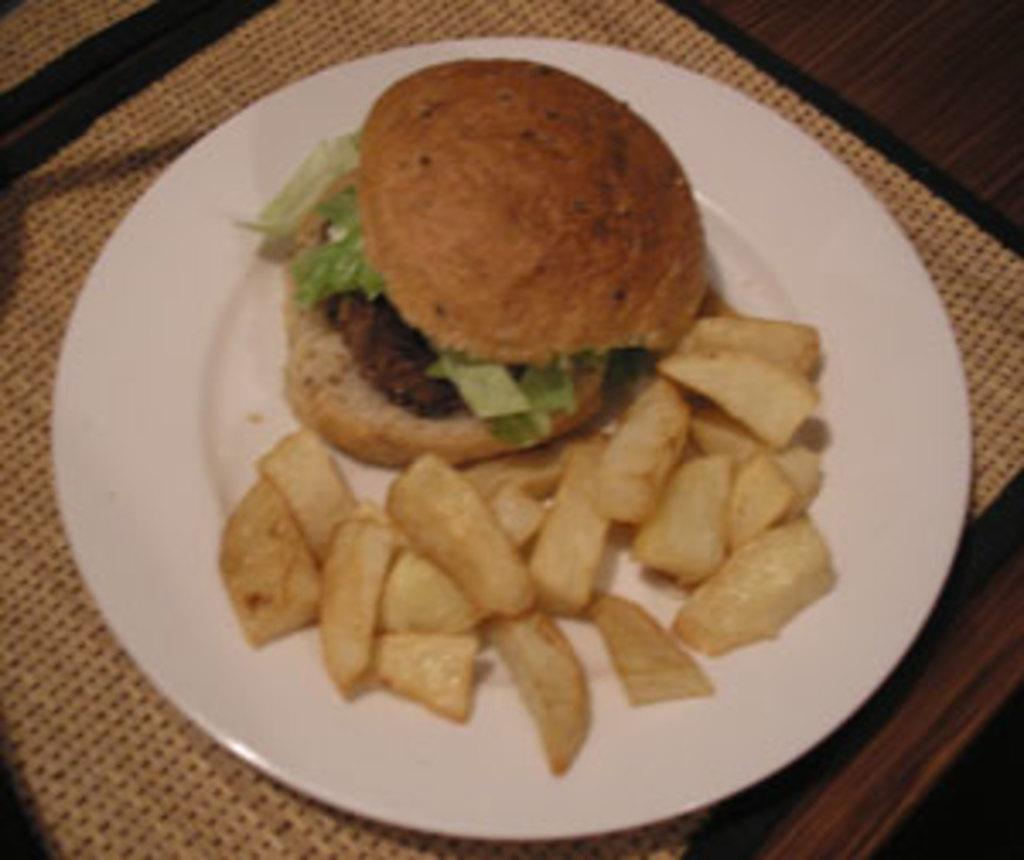What object is present on the table in the image? There is a plate on the table in the image. What is on the plate? There is a burger and french fries on the plate. What type of ring can be seen on the burger in the image? There is no ring present on the burger in the image. What kind of glove is being used to handle the french fries in the image? There is no glove visible in the image, and the french fries are not being handled by anyone. 